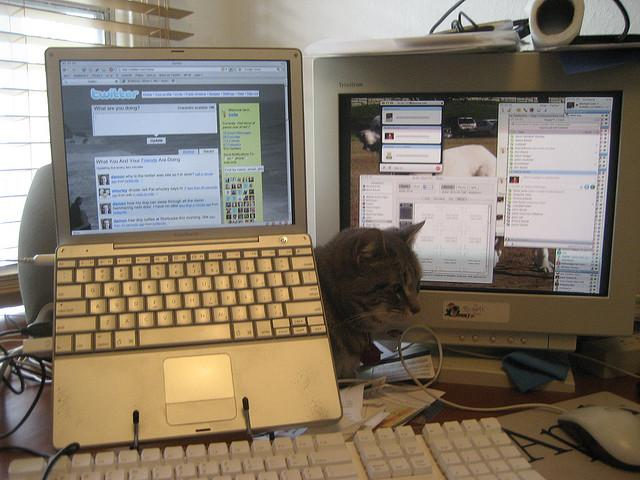What is the cat hiding behind? Please explain your reasoning. laptop. The laptop is propped up and the cat is behind it 